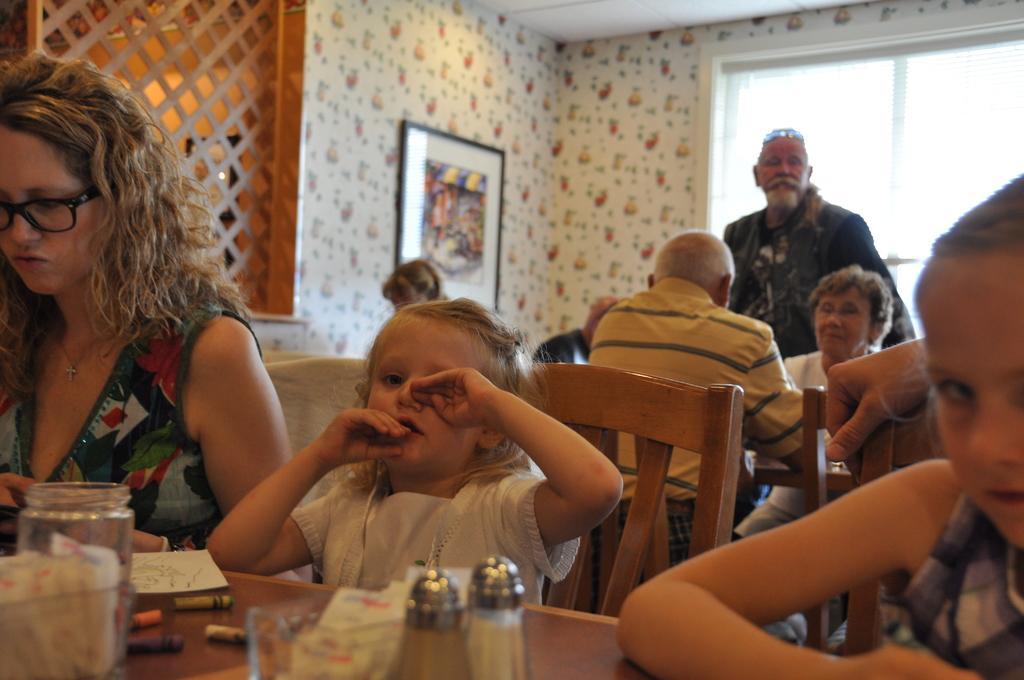Please provide a concise description of this image. There are two girls and one lady sitting in front of the table with jar crayons, paper and bottle on it. And in the background there are some people sitting and there is a men with black jacket is standing. And to the left side wall there is a frame. And in the background there is a window. 